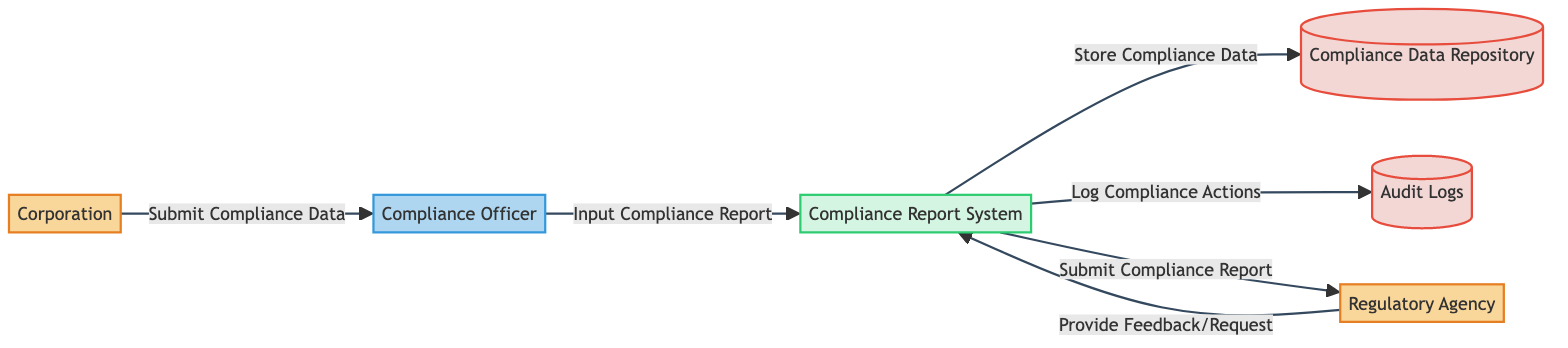What is the external entity that submits compliance data? The external entity responsible for submitting compliance data is identified as "Corporation" in the diagram.
Answer: Corporation How many data stores are present in the diagram? The diagram contains two data stores, which are "Compliance Data Repository" and "Audit Logs."
Answer: 2 What type of actor is involved in the compliance reporting workflow? The actor involved in the compliance reporting workflow is labeled as "Compliance Officer," which indicates the role they play in the process.
Answer: Compliance Officer What does the Compliance Report System do with the compliance data? The Compliance Report System processes compliance data by storing it in the "Compliance Data Repository" and logging actions in "Audit Logs." This shows the data flow from the Compliance Report System to these data stores.
Answer: Store Compliance Data What is the direction of the data flow between the Regulatory Agency and the Compliance Report System? The data flow direction is indicated as going from the "Regulatory Agency" to the "Compliance Report System," which represents the action of providing feedback or requests.
Answer: Provide Feedback/Request What is the first action taken in the compliance reporting workflow? The first action in the workflow is that the "Corporation" submits compliance data to the "Compliance Officer," establishing the starting point of the process.
Answer: Submit Compliance Data Which process stores compliance data and logs compliance actions? The "Compliance Report System" is the process that handles both storing compliance data and logging compliance actions as depicted in the flow diagram.
Answer: Compliance Report System What type of data flow occurs after the Compliance Officer inputs the compliance report? After the Compliance Officer inputs the compliance report, the data flows from the "Compliance Report System" to the "Regulatory Agency," indicating the submission of the compliance report.
Answer: Submit Compliance Report 